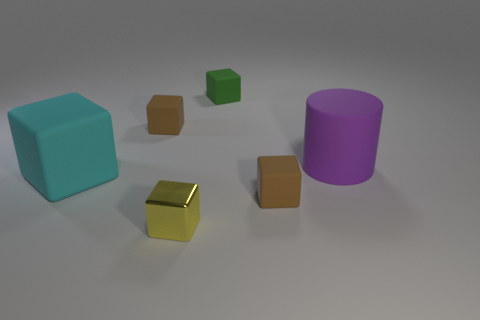There is a green rubber block; does it have the same size as the brown matte thing behind the purple matte thing?
Your answer should be compact. Yes. What is the shape of the brown matte thing that is on the right side of the metallic object?
Provide a short and direct response. Cube. Is there any other thing that has the same shape as the large purple matte thing?
Offer a terse response. No. Are there any brown matte things?
Make the answer very short. Yes. Is the size of the brown object behind the large matte cylinder the same as the brown block that is in front of the large block?
Offer a very short reply. Yes. What is the object that is both on the left side of the tiny metal block and to the right of the cyan rubber object made of?
Offer a very short reply. Rubber. There is a cyan object; how many cyan blocks are in front of it?
Your response must be concise. 0. Is there any other thing that is the same size as the yellow shiny thing?
Offer a terse response. Yes. What is the color of the big block that is the same material as the tiny green thing?
Make the answer very short. Cyan. Is the shape of the small green object the same as the large purple rubber thing?
Give a very brief answer. No. 